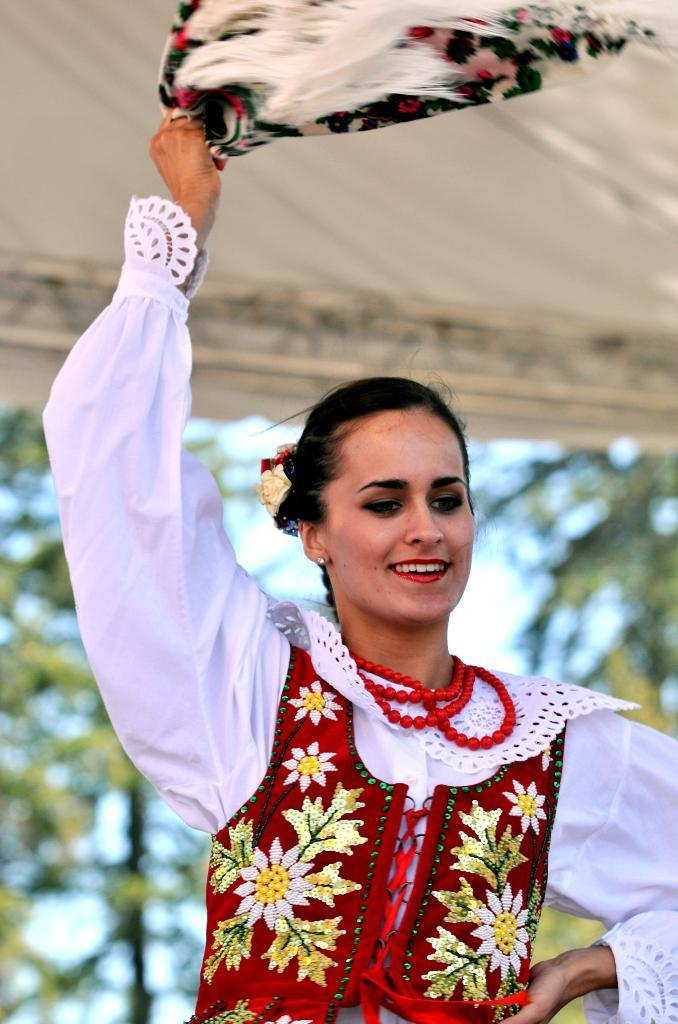Who is present in the image? There is a woman in the image. What is the woman wearing? The woman is wearing a white and red color dress. What is the woman's facial expression? The woman is smiling. What is the woman holding in her hand? The woman is holding a cloth in her hand. What can be seen in the background of the image? There are trees and the sky visible in the background of the image. What time of day is it in the image, and is the woman resting? The time of day is not mentioned in the image, and there is no indication that the woman is resting. 